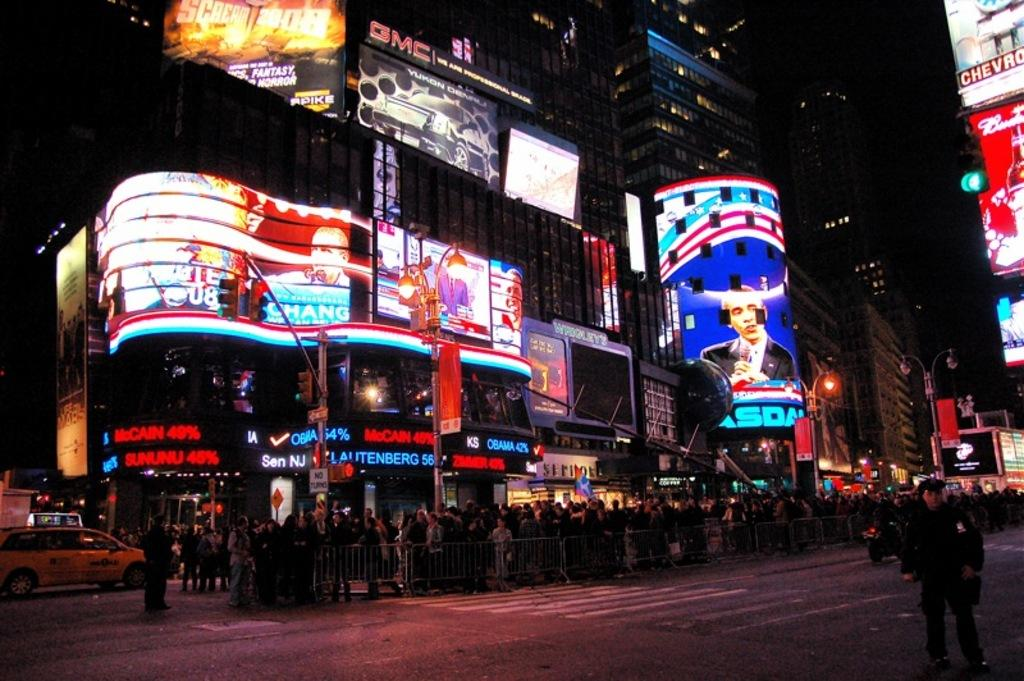<image>
Provide a brief description of the given image. Time square with lights that say mccain 49% and sununu 45% 